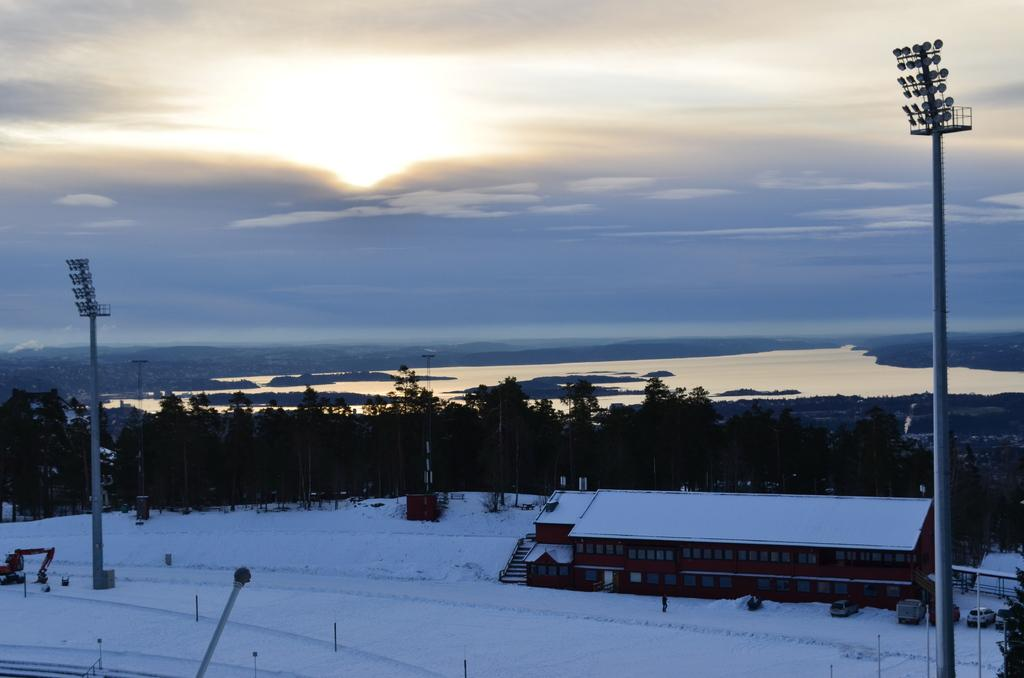What type of structure is in the picture? There is a house in the picture. What feature can be seen on the house? The house has windows. What else is present in the picture besides the house? There are vehicles, snow, poles, lights, trees, and the sky visible in the picture. Where is the maid located in the picture? There is no maid present in the picture. What type of roll is being used to create the snow in the picture? There is no roll or any indication of a roll being used to create the snow in the picture; it is a natural occurrence. 